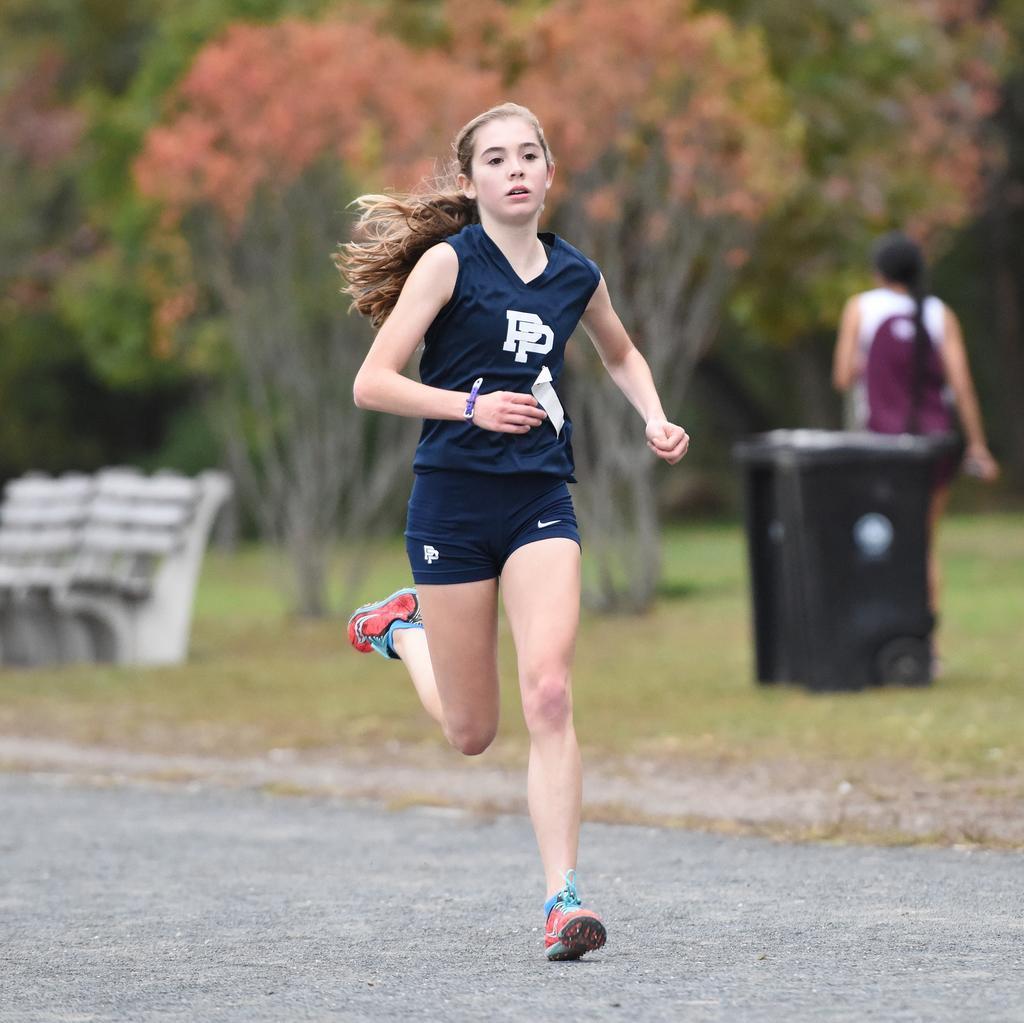Please provide a concise description of this image. In the foreground of this image, there is a girl running on the road. In the background, there are trees, a bench, a black color object and a woman walking on the grass. 